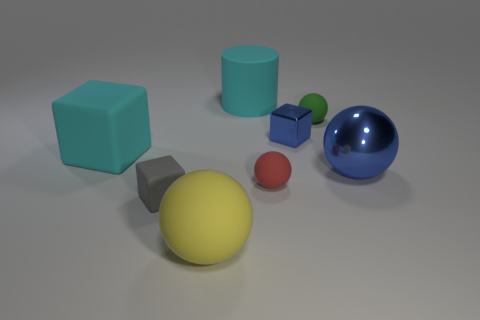Can you tell me if the large blue sphere is bigger than the green cube next to it? Certainly, observing the objects, the large blue sphere appears to have a greater diameter than the side length of the green cube beside it, indicating the sphere’s larger size. 